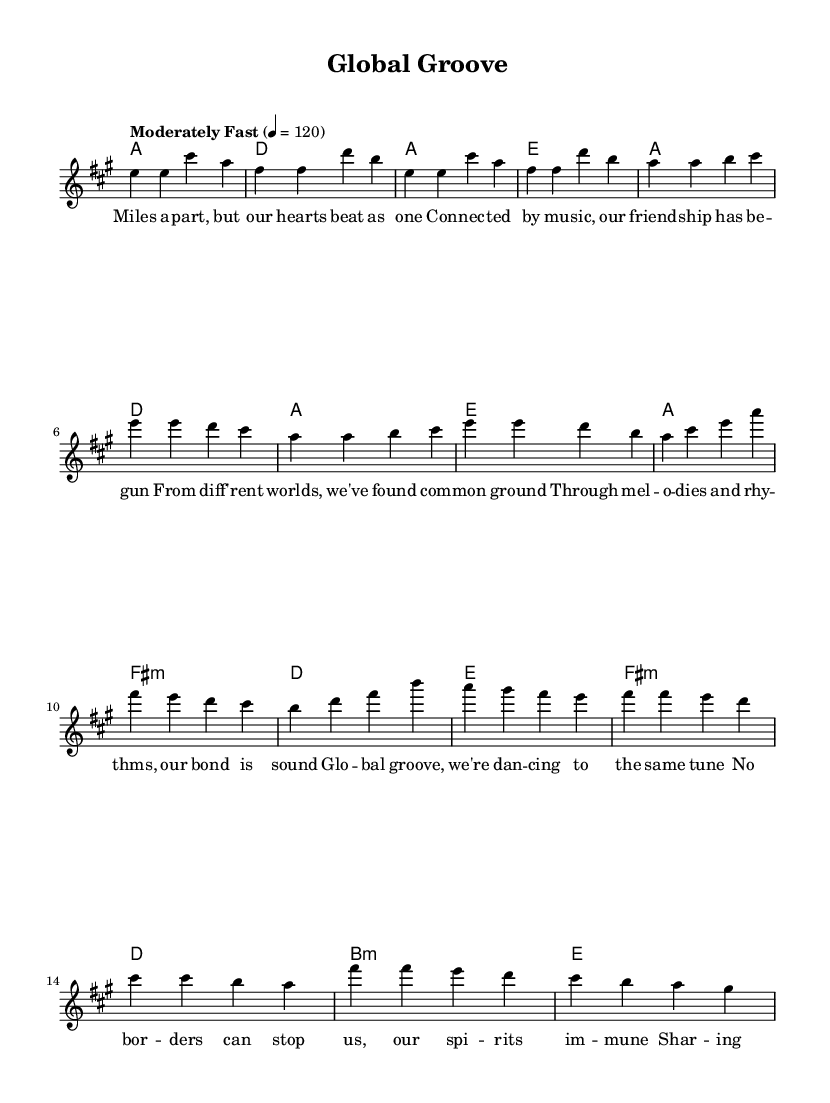What is the key signature of this music? The key signature is shown at the beginning of the staff and indicates the key of A major, which has three sharps: F sharp, C sharp, and G sharp.
Answer: A major What is the time signature of this piece? The time signature is displayed at the beginning of the score, indicating that it is in four-four time, meaning there are four beats in a measure and the quarter note gets one beat.
Answer: 4/4 What is the tempo marking for this music? The tempo marking is found at the beginning of the piece, stating "Moderately Fast" with a metronome marking of 120 beats per minute, which guides the performers on how quick to play.
Answer: Moderately Fast 120 How many measures are in the verse section? The verse consists of four lines of music, with each line made up of four measures. Therefore, you multiply the number of lines by the number of measures per line: 4 lines * 4 measures = 16 measures total.
Answer: 16 What is the chord for the chorus? The harmonies written in the chord mode show that the chords for the chorus include A major, F sharp minor, D major, and E major, which are common chord progressions used in blues music.
Answer: A, F sharp minor, D, E What theme does the bridge section convey compared to the verse? The bridge, marked by a different musical line and harmony, introduces a change in emotion and melody, contrasting with the more repetitive verses by exploring different notes and harmonies. This shift is characteristic of blues music, providing depth and diversity in the storytelling.
Answer: Contrast in emotion and melody What musical characteristics make this piece a blues-pop fusion? The fusion is achieved through the use of traditional blues elements like the chord progression (I-IV-V) along with a pop sensibility in the upbeat tempo and melodic structure, making it both accessible and reflective of the blues genre.
Answer: Upbeat tempo and blues chord progression 